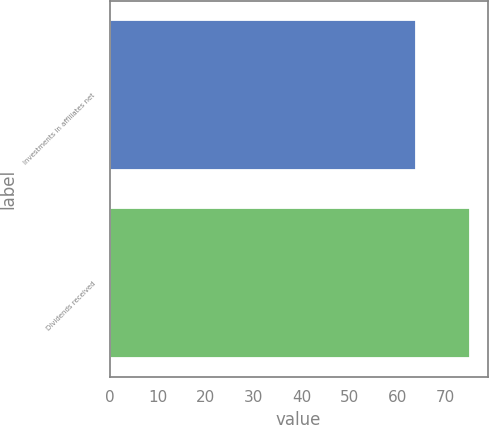Convert chart. <chart><loc_0><loc_0><loc_500><loc_500><bar_chart><fcel>Investments in affiliates net<fcel>Dividends received<nl><fcel>63.9<fcel>75.1<nl></chart> 